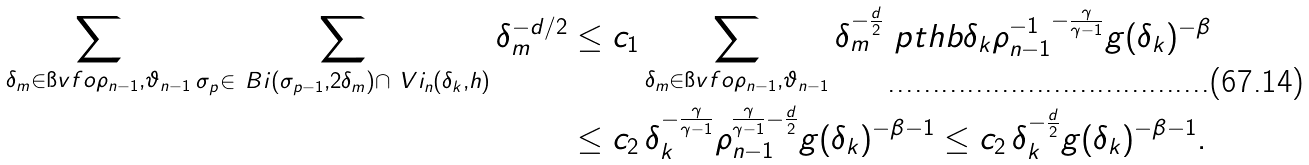Convert formula to latex. <formula><loc_0><loc_0><loc_500><loc_500>\sum _ { \delta _ { m } \in \i v f o { \rho _ { n - 1 } , \vartheta _ { n - 1 } } } \sum _ { \sigma _ { p } \in \ B i ( \sigma _ { p - 1 } , 2 \delta _ { m } ) \cap \ V i _ { n } ( \delta _ { k } , h ) } \delta _ { m } ^ { - d / 2 } & \leq c _ { 1 } \sum _ { \delta _ { m } \in \i v f o { \rho _ { n - 1 } , \vartheta _ { n - 1 } } } \delta _ { m } ^ { - \frac { d } { 2 } } \ p t h b { \delta _ { k } \rho _ { n - 1 } ^ { - 1 } } ^ { - \frac { \gamma } { \gamma - 1 } } g ( \delta _ { k } ) ^ { - \beta } \\ & \leq c _ { 2 } \, \delta _ { k } ^ { - \frac { \gamma } { \gamma - 1 } } \rho _ { n - 1 } ^ { { \frac { \gamma } { \gamma - 1 } - \frac { d } { 2 } } } g ( \delta _ { k } ) ^ { - \beta - 1 } \leq c _ { 2 } \, \delta _ { k } ^ { - \frac { d } { 2 } } g ( \delta _ { k } ) ^ { - \beta - 1 } .</formula> 